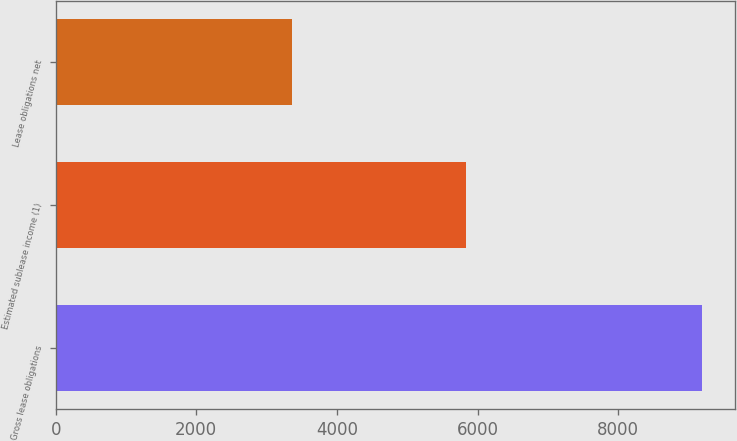Convert chart to OTSL. <chart><loc_0><loc_0><loc_500><loc_500><bar_chart><fcel>Gross lease obligations<fcel>Estimated sublease income (1)<fcel>Lease obligations net<nl><fcel>9196<fcel>5840<fcel>3356<nl></chart> 